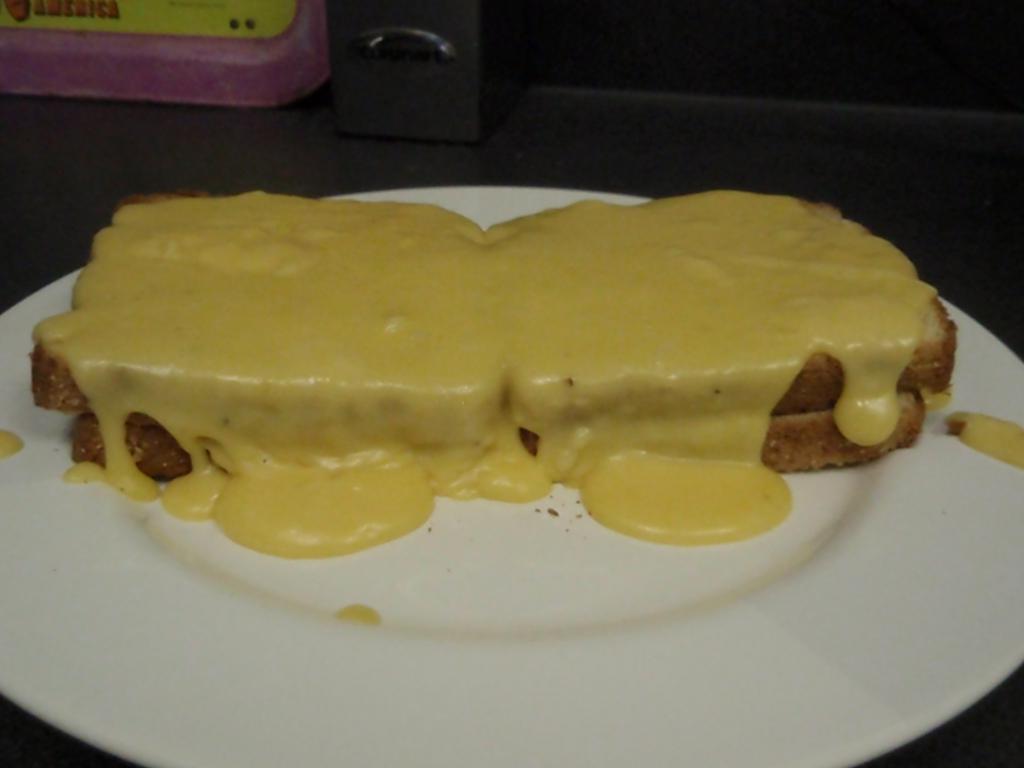Could you give a brief overview of what you see in this image? In this picture there is an edible placed on a plate and there are some other objects in the background. 